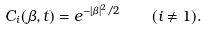Convert formula to latex. <formula><loc_0><loc_0><loc_500><loc_500>C _ { i } ( \beta , t ) = e ^ { - | \beta | ^ { 2 } / 2 } \quad ( i \neq 1 ) .</formula> 